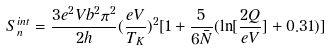<formula> <loc_0><loc_0><loc_500><loc_500>S _ { n } ^ { i n t } = \frac { 3 e ^ { 2 } V b ^ { 2 } \pi ^ { 2 } } { 2 h } ( \frac { e V } { T _ { K } } ) ^ { 2 } [ 1 + \frac { 5 } { 6 \bar { N } } ( \ln [ \frac { 2 Q } { e V } ] + 0 . 3 1 ) ]</formula> 